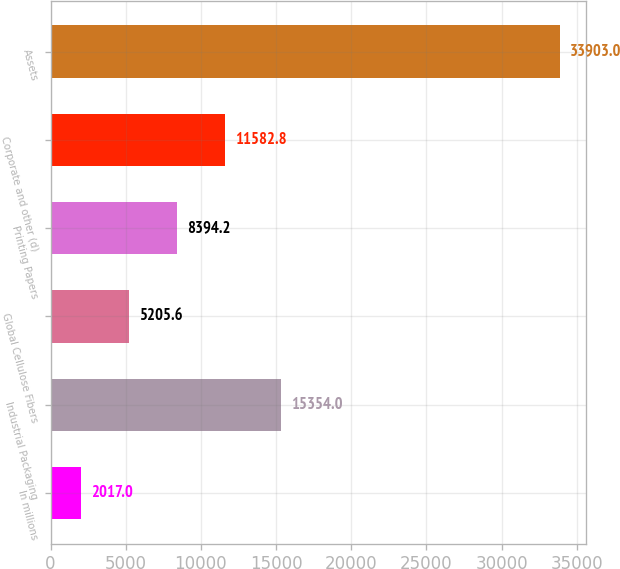Convert chart. <chart><loc_0><loc_0><loc_500><loc_500><bar_chart><fcel>In millions<fcel>Industrial Packaging<fcel>Global Cellulose Fibers<fcel>Printing Papers<fcel>Corporate and other (d)<fcel>Assets<nl><fcel>2017<fcel>15354<fcel>5205.6<fcel>8394.2<fcel>11582.8<fcel>33903<nl></chart> 